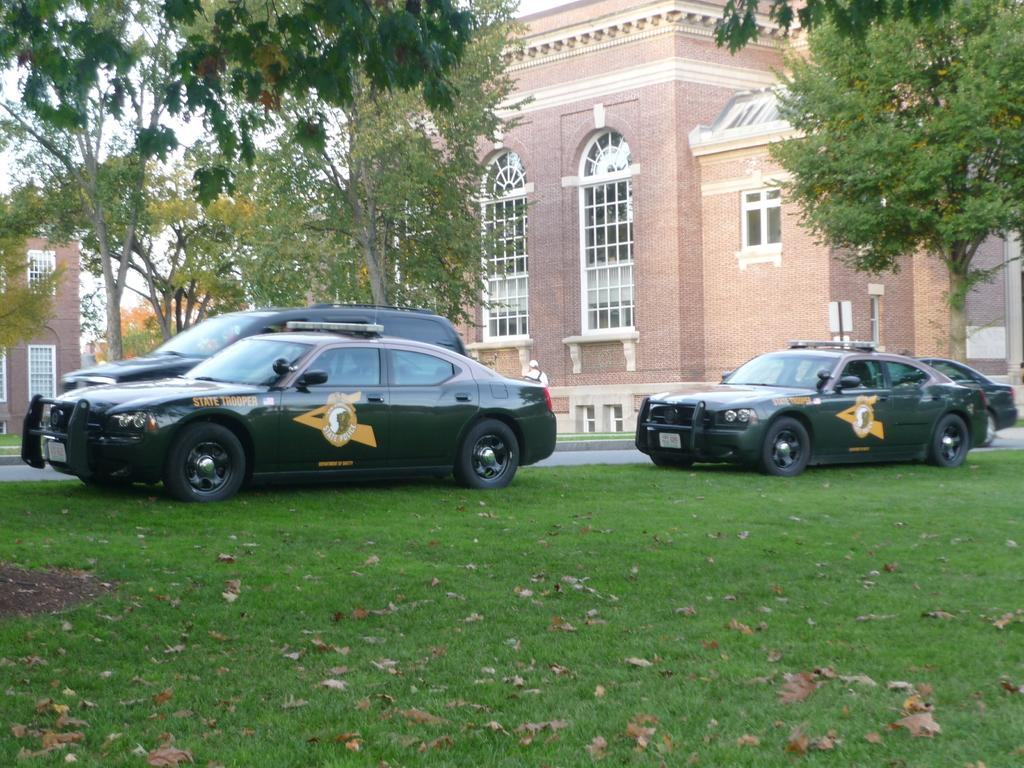How many cars are present in the image? There are four cars in the image. Where are the cars located in relation to the building? The cars are parked in front of a building. What type of vegetation is beside the cars? There are trees beside the cars. What type of ground cover is visible in the image? There is grass visible in the image. Who is the creator of the grass in the image? The image does not provide information about the creator of the grass; it is a natural element. 